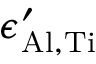<formula> <loc_0><loc_0><loc_500><loc_500>\epsilon _ { A l , T i } ^ { \prime }</formula> 